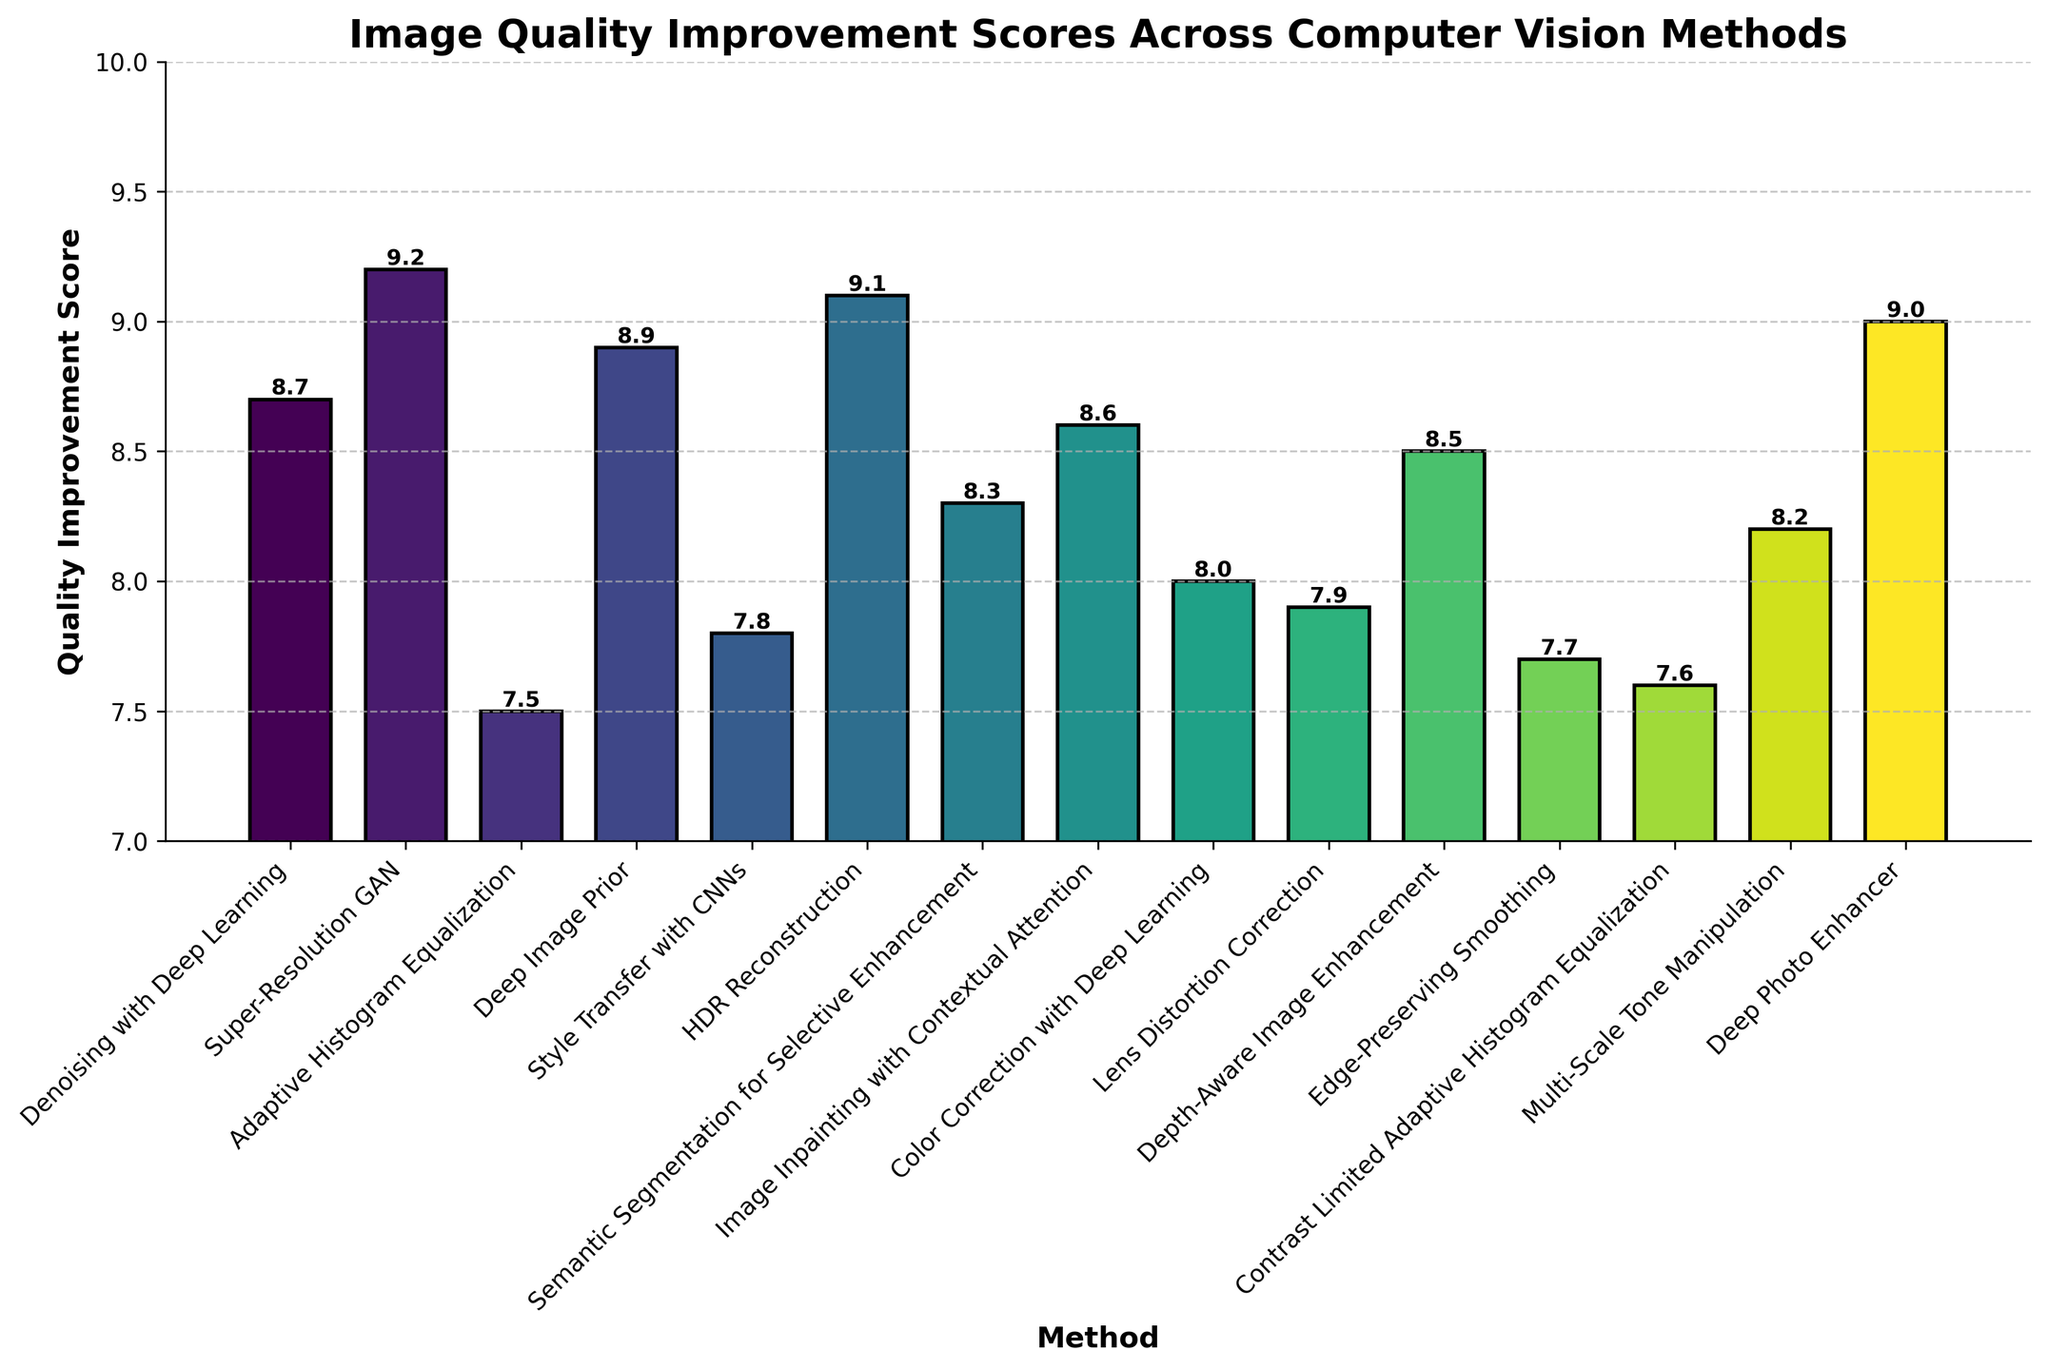Which method has the highest quality improvement score? The bar chart shows the scores. The highest bar corresponds to the 'Super-Resolution GAN' method with a score of 9.2.
Answer: Super-Resolution GAN What is the difference in scores between 'Deep Photo Enhancer' and 'Adaptive Histogram Equalization'? From the bar chart, 'Deep Photo Enhancer' has a score of 9.0 and 'Adaptive Histogram Equalization' has a score of 7.5. Subtracting these gives a difference of 1.5.
Answer: 1.5 How many methods have a quality improvement score of 9.0 or higher? By looking at the chart, the methods with scores 9.0 or higher are 'Super-Resolution GAN', 'HDR Reconstruction', and 'Deep Photo Enhancer', making a total of 3 methods.
Answer: 3 Which method has the lowest quality improvement score and what is that score? The shortest bar represents the lowest score which is 'Adaptive Histogram Equalization' with a score of 7.5.
Answer: Adaptive Histogram Equalization, 7.5 What is the average quality improvement score of all methods? Sum the scores of all methods and divide by the number of methods (15). Total sum is 122.3, so the average score is 122.3/15=8.15.
Answer: 8.15 Which method is slightly better than 'Depth-Aware Image Enhancement' in terms of score? 'Depth-Aware Image Enhancement' has a score of 8.5. The method with a slightly higher score is 'Deep Image Prior' with a score of 8.9.
Answer: Deep Image Prior By how much does 'Image Inpainting with Contextual Attention' score exceed 'Color Correction with Deep Learning'? 'Image Inpainting with Contextual Attention' has a score of 8.6 while 'Color Correction with Deep Learning' has 8.0. The difference is 8.6 - 8.0 = 0.6.
Answer: 0.6 Are there any methods that have the same score? Observing all the bars, there are no two methods that have the exact same score.
Answer: No What is the score range of the methods shown on the chart? The highest score is 9.2 and the lowest score is 7.5, thus the range is 9.2 - 7.5 = 1.7.
Answer: 1.7 